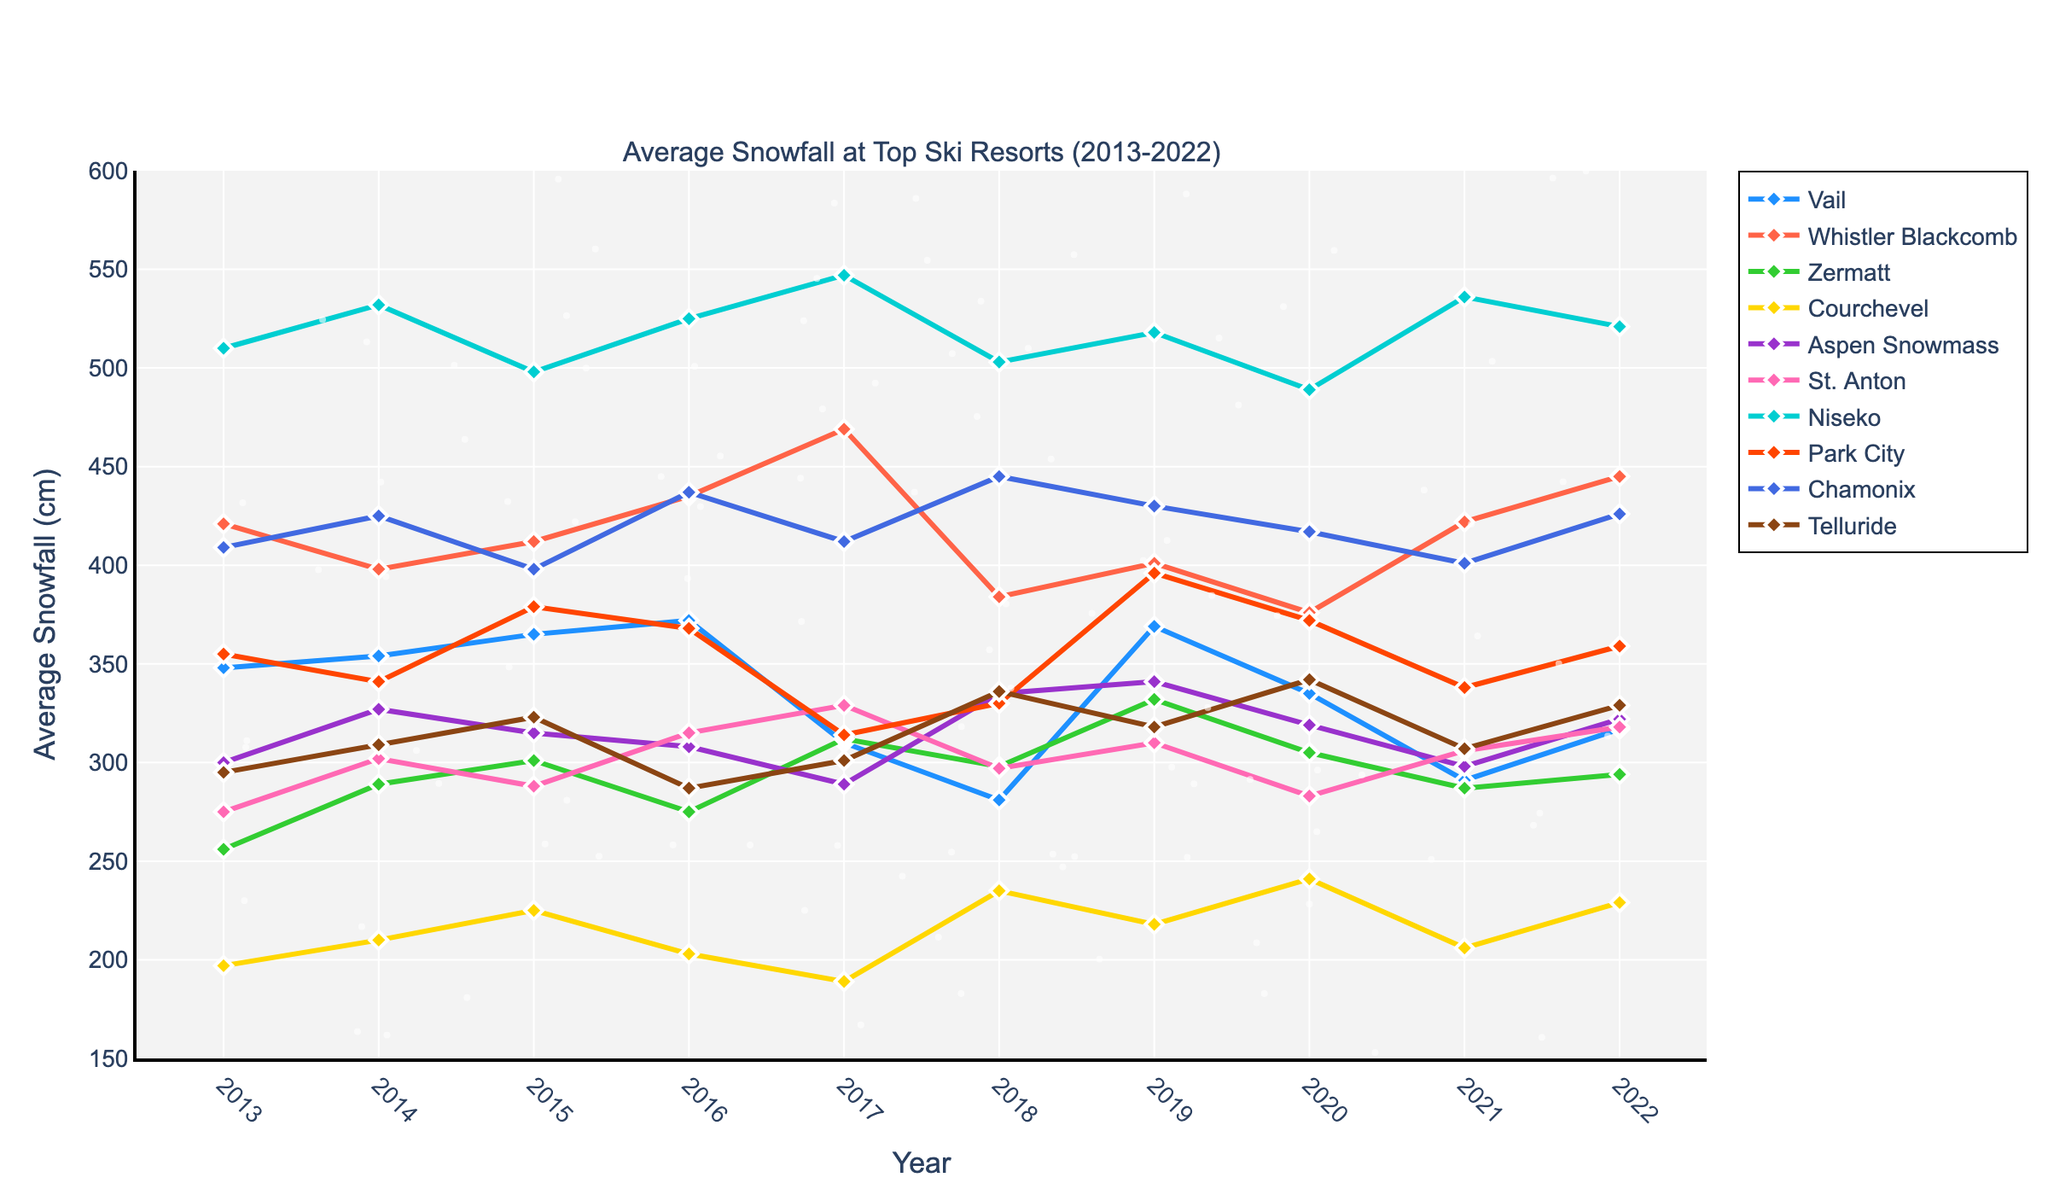What's the resort with the highest average snowfall in 2022? To determine the resort with the highest average snowfall in 2022, look for the peak value in the graph corresponding to the year 2022. The tallest point will indicate the highest snowfall.
Answer: Whistler Blackcomb Which year did Courchevel experience its maximum snowfall? Inspect the trajectory of the line corresponding to Courchevel and identify the peak value throughout the decade. Note the corresponding year of this peak.
Answer: 2018 Compare the snowfall of Chamonix and Niseko in 2017; which one had more? Locate the snowfall values for the year 2017 on the graph. Identify both resorts' points for that year and see which one is higher.
Answer: Niseko Which resort had the biggest increase in snowfall from 2013 to 2014? Compare the differences in snowfall between 2013 and 2014 for all resorts. Identify the resort with the largest difference. Calculate differences can assist: Vail (354-348), Whistler Blackcomb (398-421), etc.
Answer: Aspen Snowmass Which resort had the most fluctuation in snowfall over the decade? A resort with significant ups and downs in its line trajectory indicates more fluctuation. Check for the line with the steepest and most frequent changes.
Answer: Niseko What was the average snowfall of Aspen Snowmass from 2018 to 2022? Calculate the average snowfall of Aspen Snowmass over these years by summing up the snowfalls and dividing by the number of years: (335+341+319+298+322)/5.
Answer: 323 Across all resorts, which year had the lowest cumulative snowfall? Sum the snowfalls of all resorts for each year and compare to find the minimum total snowfall.
Answer: 2018 How did the snowfall trend for Zermatt change from 2013 to 2022? Observe the trend line for Zermatt and note if the line generally inclines, declines, or remains stable over these years.
Answer: Slightly increasing Did Telluride ever record an average snowfall greater than 350 cm in the decade? Check the line corresponding to Telluride and see if it crosses the 350 cm mark at any point.
Answer: No Visually, which resort used a green line for its snowfall data? Identify the resort whose line color is green.
Answer: Zermatt 